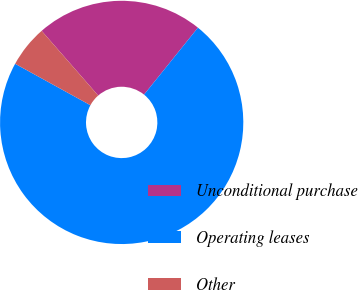Convert chart to OTSL. <chart><loc_0><loc_0><loc_500><loc_500><pie_chart><fcel>Unconditional purchase<fcel>Operating leases<fcel>Other<nl><fcel>22.22%<fcel>72.22%<fcel>5.56%<nl></chart> 